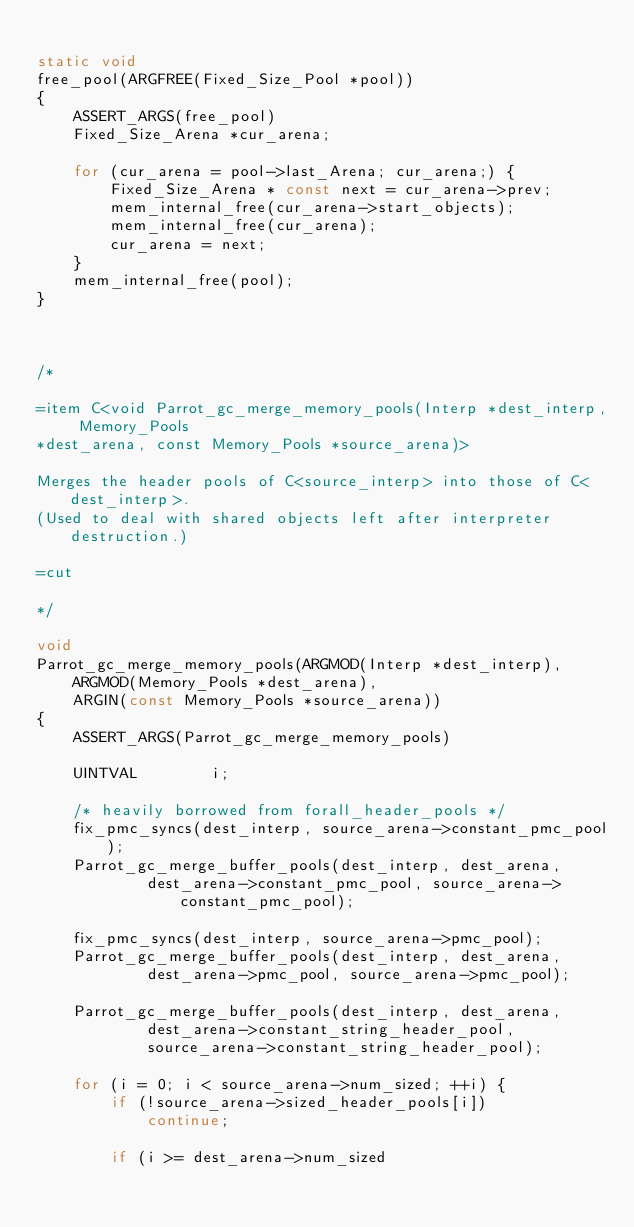<code> <loc_0><loc_0><loc_500><loc_500><_C_>
static void
free_pool(ARGFREE(Fixed_Size_Pool *pool))
{
    ASSERT_ARGS(free_pool)
    Fixed_Size_Arena *cur_arena;

    for (cur_arena = pool->last_Arena; cur_arena;) {
        Fixed_Size_Arena * const next = cur_arena->prev;
        mem_internal_free(cur_arena->start_objects);
        mem_internal_free(cur_arena);
        cur_arena = next;
    }
    mem_internal_free(pool);
}



/*

=item C<void Parrot_gc_merge_memory_pools(Interp *dest_interp, Memory_Pools
*dest_arena, const Memory_Pools *source_arena)>

Merges the header pools of C<source_interp> into those of C<dest_interp>.
(Used to deal with shared objects left after interpreter destruction.)

=cut

*/

void
Parrot_gc_merge_memory_pools(ARGMOD(Interp *dest_interp),
    ARGMOD(Memory_Pools *dest_arena),
    ARGIN(const Memory_Pools *source_arena))
{
    ASSERT_ARGS(Parrot_gc_merge_memory_pools)

    UINTVAL        i;

    /* heavily borrowed from forall_header_pools */
    fix_pmc_syncs(dest_interp, source_arena->constant_pmc_pool);
    Parrot_gc_merge_buffer_pools(dest_interp, dest_arena,
            dest_arena->constant_pmc_pool, source_arena->constant_pmc_pool);

    fix_pmc_syncs(dest_interp, source_arena->pmc_pool);
    Parrot_gc_merge_buffer_pools(dest_interp, dest_arena,
            dest_arena->pmc_pool, source_arena->pmc_pool);

    Parrot_gc_merge_buffer_pools(dest_interp, dest_arena,
            dest_arena->constant_string_header_pool,
            source_arena->constant_string_header_pool);

    for (i = 0; i < source_arena->num_sized; ++i) {
        if (!source_arena->sized_header_pools[i])
            continue;

        if (i >= dest_arena->num_sized</code> 